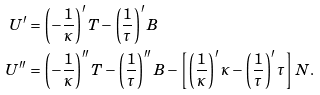<formula> <loc_0><loc_0><loc_500><loc_500>U ^ { \prime } & = \left ( - \frac { 1 } { \kappa } \right ) ^ { \prime } T - \left ( \frac { 1 } { \tau } \right ) ^ { \prime } B \\ U ^ { \prime \prime } & = \left ( - \frac { 1 } { \kappa } \right ) ^ { \prime \prime } T - \left ( \frac { 1 } { \tau } \right ) ^ { \prime \prime } B - \left [ \left ( \frac { 1 } { \kappa } \right ) ^ { \prime } \kappa - \left ( \frac { 1 } { \tau } \right ) ^ { \prime } \tau \right ] N .</formula> 